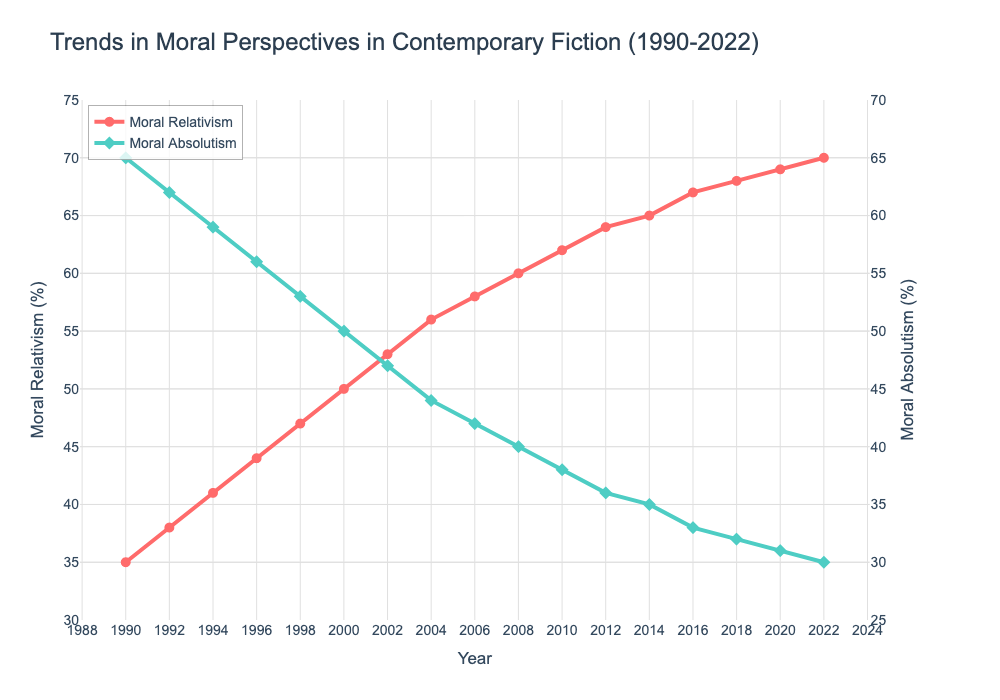What is the trend for Moral Relativism from 1990 to 2022? The trend for Moral Relativism can be determined by observing the slope of the line corresponding to this variable over the years. The line increases steadily, indicating an upward trend.
Answer: Upward trend How does the representation of Moral Absolutism in 2000 compare to that of 2022? To compare the representation, look at the y-values for Moral Absolutism in 2000 and 2022. In 2000, it is 50%, and in 2022, it is 30%.
Answer: Decreased by 20% What year did Moral Relativism and Moral Absolutism represent equal values? The year where the trend lines for both Moral Relativism and Moral Absolutism intersect indicates equality. This occurs around the year 2000.
Answer: 2000 By how many percentage points did Moral Relativism increase from 1990 to 2022? Find the percentage increase by subtracting the value for Moral Relativism in 1990 from that in 2022. (70% - 35%)
Answer: 35 percentage points In which year does Moral Relativism cross the 50% mark? Check the plot for the year where the line for Moral Relativism reaches 50%. This happens in the year 2000.
Answer: 2000 What is the average representation of Moral Relativism over three decades? Calculate the average by adding the values from each year and dividing by the number of years (sum(35, 38, ..., 70) / 17).
Answer: 54.24% Between which two consecutive years did Moral Absolutism show the greatest decline? Observe the steepness of the downward slopes in the Moral Absolutism line and compare sequential years. The steepest slope is between 2000 and 2002 where the difference is (50% - 47%) = 3 percentage points.
Answer: 2000-2002 How many years did the value of Moral Absolutism remain above 40%? Identify and count the years where the Moral Absolutism line is above 40%. Moral Absolutism remained above 40% from 1990 to 2006, totaling 9 years.
Answer: 9 years 